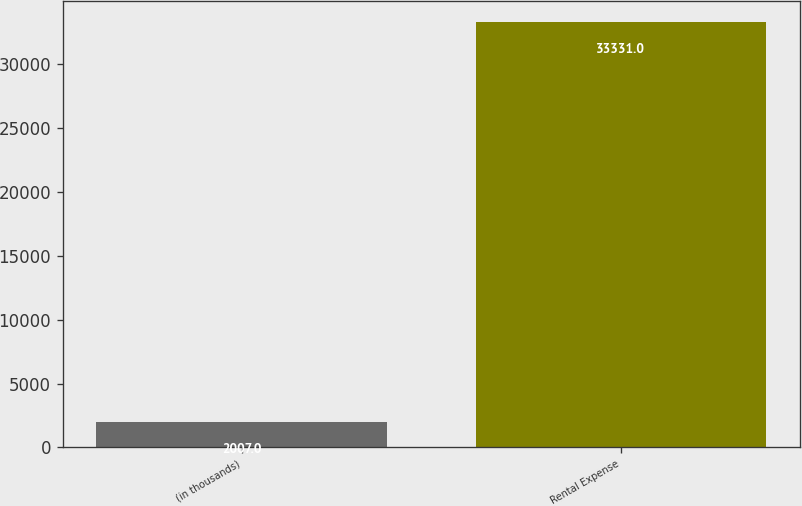Convert chart to OTSL. <chart><loc_0><loc_0><loc_500><loc_500><bar_chart><fcel>(in thousands)<fcel>Rental Expense<nl><fcel>2007<fcel>33331<nl></chart> 